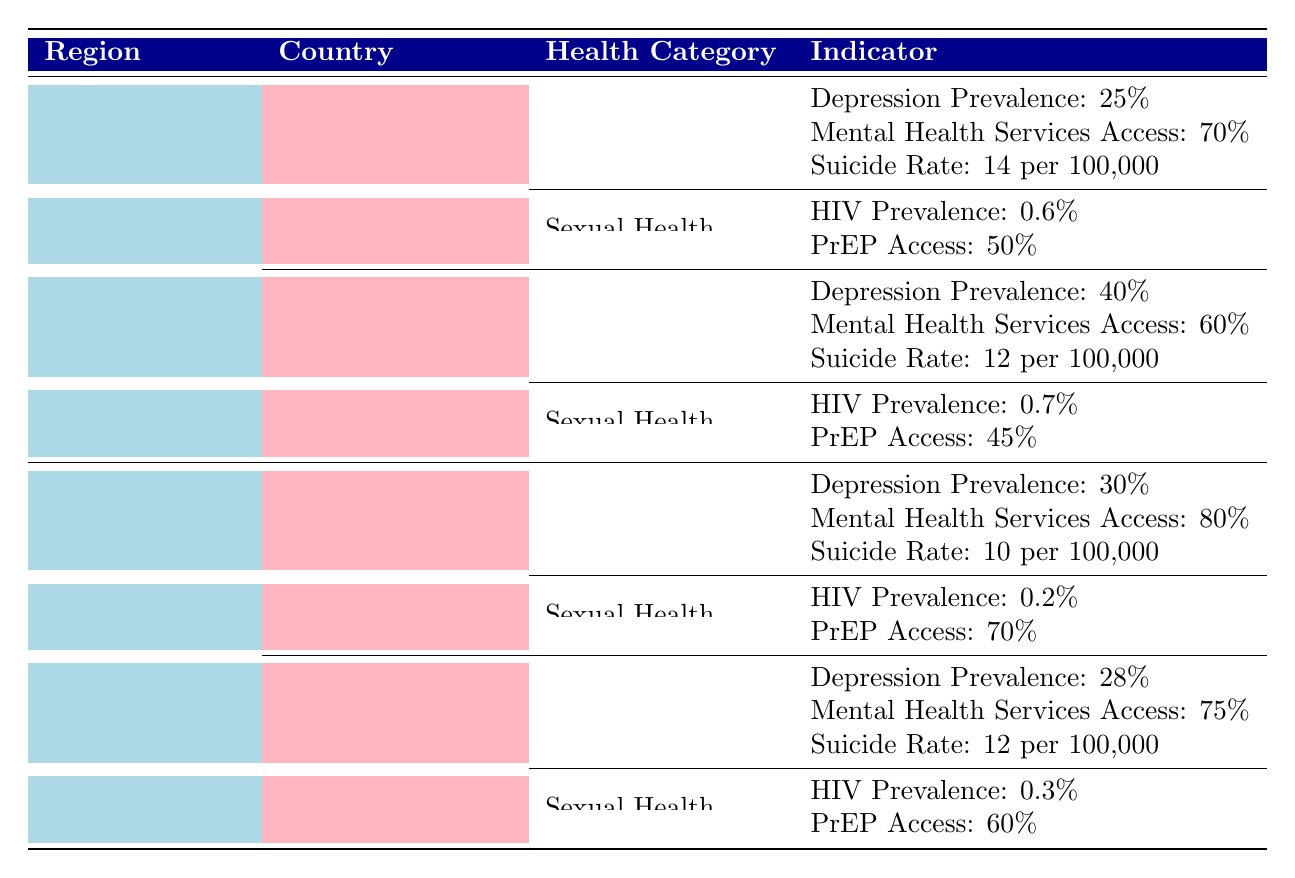What is the prevalence of depression in Uruguay? The table states that the prevalence of depression in Uruguay is 25%, so we can directly retrieve this value from the relevant row.
Answer: 25% What is the suicide rate in Germany? According to the table, the suicide rate in Germany is listed as 12 per 100,000 individuals. We refer to the specific row for Germany under Mental Health.
Answer: 12 per 100,000 individuals Is HIV prevalence higher in Brazil than in the United Kingdom? The table shows that Brazil has an HIV prevalence of 0.7% and the United Kingdom has 0.2%. Since 0.7% is greater than 0.2%, the statement is true.
Answer: Yes What percentage of LGBTQ+ individuals in Uruguay have access to mental health services? The table indicates that access to mental health services in Uruguay is 70%. We find this information in the corresponding row for Mental Health under Uruguay.
Answer: 70% What is the average prevalence of depression in Latin America based on the provided countries? For Uruguay, the prevalence of depression is 25% and for Brazil, it's 40%. We sum these values (25 + 40) = 65 and then divide by the number of countries (2), which gives us an average of 32.5%.
Answer: 32.5% Do more individuals in the United Kingdom have access to PrEP compared to those in Brazil? The table states that PrEP access in the United Kingdom is 70% while in Brazil, it is 45%. Since 70% is greater than 45%, the answer is yes.
Answer: Yes What is the difference in access to mental health services between Uruguay and Germany? According to the table, Uruguay has access to mental health services at 70% and Germany at 75%. The difference is 75 - 70 = 5%.
Answer: 5% What is the lowest HIV prevalence among the countries listed? From the data, the HIV prevalence in Uruguay is 0.6%, in Brazil it’s 0.7%, in the United Kingdom it’s 0.2%, and in Germany it’s 0.3%. The lowest value is 0.2%, which corresponds to the United Kingdom.
Answer: 0.2% What is the total suicide rate reported in Latin America? The suicide rates in Uruguay and Brazil are 14 per 100,000 and 12 per 100,000 respectively. Adding these gives us a total of 14 + 12 = 26 per 100,000 individuals.
Answer: 26 per 100,000 individuals 